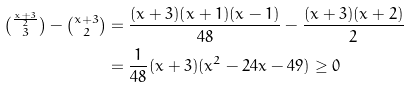<formula> <loc_0><loc_0><loc_500><loc_500>\tbinom { \frac { x + 3 } { 2 } } { 3 } - \tbinom { x + 3 } { 2 } & = \frac { ( x + 3 ) ( x + 1 ) ( x - 1 ) } { 4 8 } - \frac { ( x + 3 ) ( x + 2 ) } { 2 } \\ & = \frac { 1 } { 4 8 } ( x + 3 ) ( x ^ { 2 } - 2 4 x - 4 9 ) \geq 0</formula> 